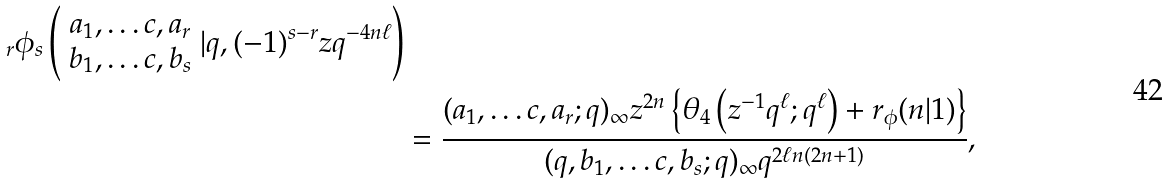<formula> <loc_0><loc_0><loc_500><loc_500>_ { r } \phi _ { s } \left ( \begin{array} { c } a _ { 1 } , \dots c , a _ { r } \\ b _ { 1 } , \dots c , b _ { s } \end{array} | q , ( - 1 ) ^ { s - r } z q ^ { - 4 n \ell } \right ) \\ & = \frac { ( a _ { 1 } , \dots c , a _ { r } ; q ) _ { \infty } z ^ { 2 n } \left \{ \theta _ { 4 } \left ( z ^ { - 1 } q ^ { \ell } ; q ^ { \ell } \right ) + r _ { \phi } ( n | 1 ) \right \} } { ( q , b _ { 1 } , \dots c , b _ { s } ; q ) _ { \infty } q ^ { 2 \ell n ( 2 n + 1 ) } } ,</formula> 